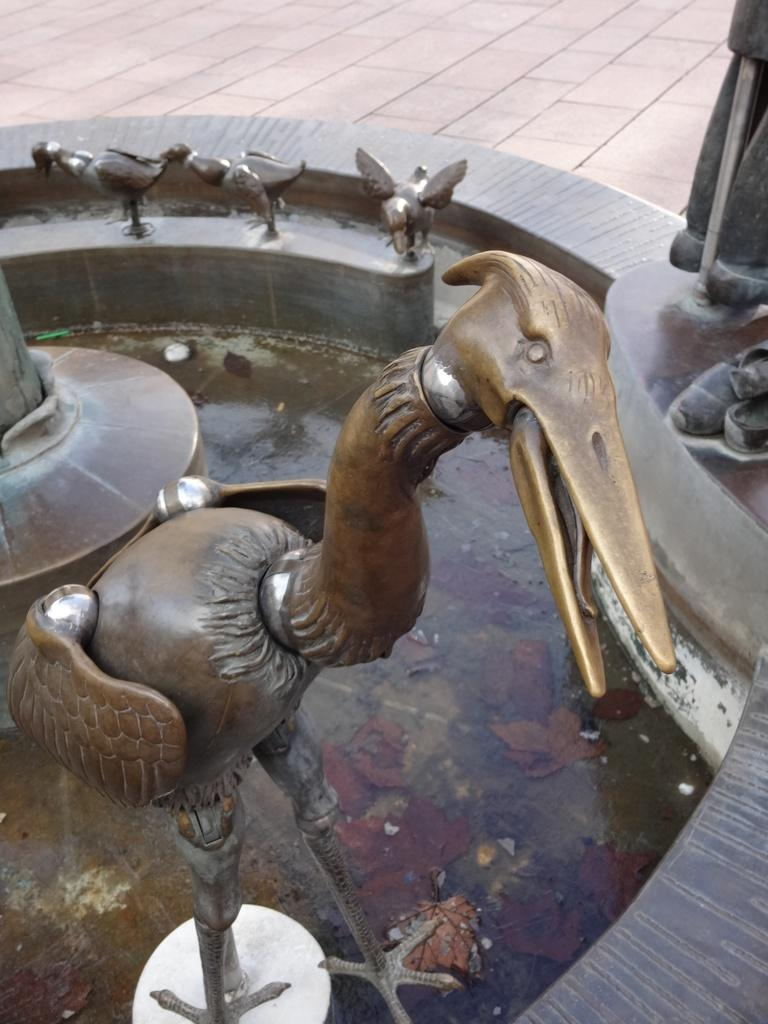What is the main feature in the image? There is a fountain in the image. What is located inside the fountain? There is a metal bird in the fountain. Are there any other metal birds in the image? Yes, there are three metal birds in the background of the image. What is the size of the car driving past the fountain in the image? There is no car driving past the fountain in the image. 